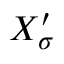<formula> <loc_0><loc_0><loc_500><loc_500>X _ { \sigma } ^ { \prime }</formula> 